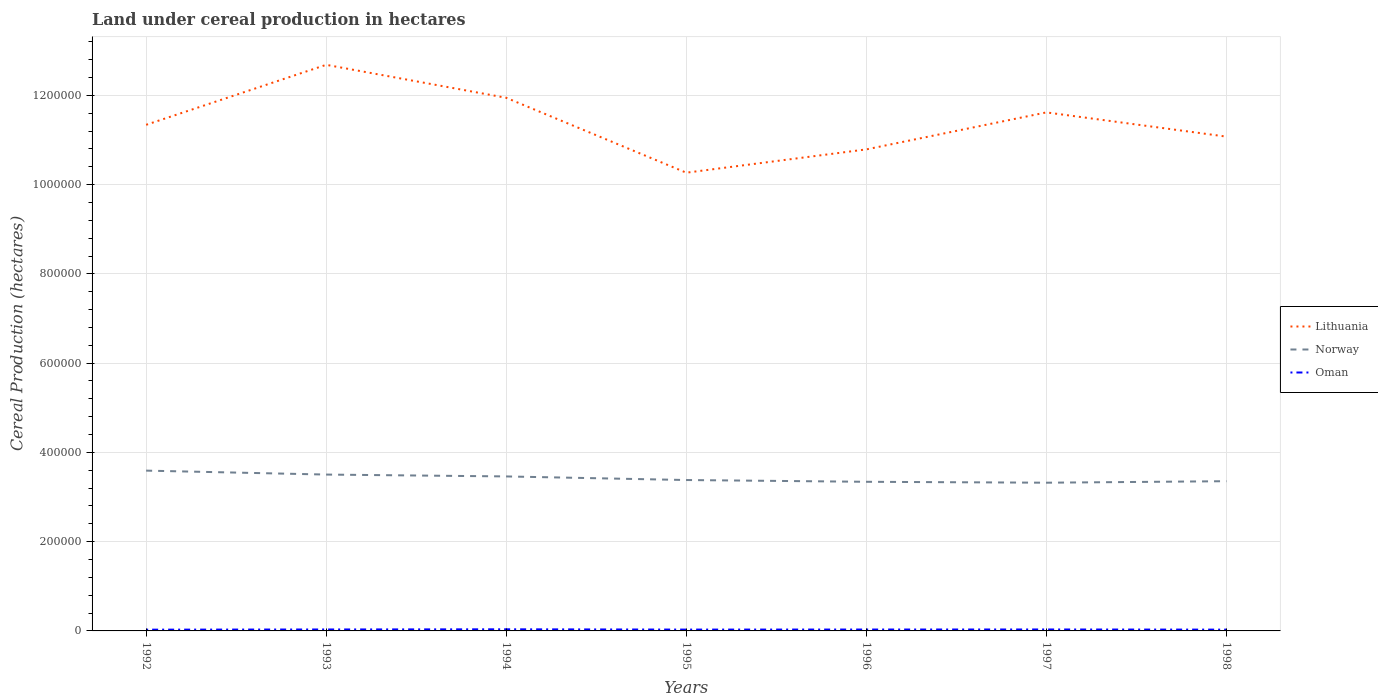How many different coloured lines are there?
Provide a short and direct response. 3. Across all years, what is the maximum land under cereal production in Oman?
Your response must be concise. 2814. What is the total land under cereal production in Oman in the graph?
Your answer should be compact. 126. What is the difference between the highest and the second highest land under cereal production in Oman?
Keep it short and to the point. 821. What is the difference between the highest and the lowest land under cereal production in Lithuania?
Your response must be concise. 3. How many years are there in the graph?
Your answer should be compact. 7. Does the graph contain any zero values?
Provide a short and direct response. No. Where does the legend appear in the graph?
Ensure brevity in your answer.  Center right. How are the legend labels stacked?
Your answer should be compact. Vertical. What is the title of the graph?
Provide a succinct answer. Land under cereal production in hectares. Does "Greece" appear as one of the legend labels in the graph?
Your answer should be very brief. No. What is the label or title of the Y-axis?
Give a very brief answer. Cereal Production (hectares). What is the Cereal Production (hectares) of Lithuania in 1992?
Offer a very short reply. 1.13e+06. What is the Cereal Production (hectares) in Norway in 1992?
Keep it short and to the point. 3.59e+05. What is the Cereal Production (hectares) in Oman in 1992?
Keep it short and to the point. 2814. What is the Cereal Production (hectares) in Lithuania in 1993?
Your answer should be very brief. 1.27e+06. What is the Cereal Production (hectares) of Norway in 1993?
Provide a succinct answer. 3.50e+05. What is the Cereal Production (hectares) in Oman in 1993?
Keep it short and to the point. 3246. What is the Cereal Production (hectares) in Lithuania in 1994?
Your response must be concise. 1.19e+06. What is the Cereal Production (hectares) in Norway in 1994?
Offer a very short reply. 3.46e+05. What is the Cereal Production (hectares) of Oman in 1994?
Keep it short and to the point. 3635. What is the Cereal Production (hectares) in Lithuania in 1995?
Your answer should be very brief. 1.03e+06. What is the Cereal Production (hectares) in Norway in 1995?
Provide a short and direct response. 3.38e+05. What is the Cereal Production (hectares) in Oman in 1995?
Keep it short and to the point. 2990. What is the Cereal Production (hectares) of Lithuania in 1996?
Give a very brief answer. 1.08e+06. What is the Cereal Production (hectares) of Norway in 1996?
Your response must be concise. 3.34e+05. What is the Cereal Production (hectares) in Oman in 1996?
Your answer should be compact. 3120. What is the Cereal Production (hectares) of Lithuania in 1997?
Provide a short and direct response. 1.16e+06. What is the Cereal Production (hectares) in Norway in 1997?
Your answer should be very brief. 3.32e+05. What is the Cereal Production (hectares) in Oman in 1997?
Make the answer very short. 3250. What is the Cereal Production (hectares) in Lithuania in 1998?
Keep it short and to the point. 1.11e+06. What is the Cereal Production (hectares) of Norway in 1998?
Your response must be concise. 3.35e+05. What is the Cereal Production (hectares) in Oman in 1998?
Your answer should be very brief. 2894. Across all years, what is the maximum Cereal Production (hectares) in Lithuania?
Ensure brevity in your answer.  1.27e+06. Across all years, what is the maximum Cereal Production (hectares) in Norway?
Offer a very short reply. 3.59e+05. Across all years, what is the maximum Cereal Production (hectares) of Oman?
Your answer should be compact. 3635. Across all years, what is the minimum Cereal Production (hectares) of Lithuania?
Offer a very short reply. 1.03e+06. Across all years, what is the minimum Cereal Production (hectares) in Norway?
Offer a very short reply. 3.32e+05. Across all years, what is the minimum Cereal Production (hectares) of Oman?
Make the answer very short. 2814. What is the total Cereal Production (hectares) of Lithuania in the graph?
Your response must be concise. 7.97e+06. What is the total Cereal Production (hectares) in Norway in the graph?
Make the answer very short. 2.40e+06. What is the total Cereal Production (hectares) in Oman in the graph?
Offer a very short reply. 2.19e+04. What is the difference between the Cereal Production (hectares) in Lithuania in 1992 and that in 1993?
Your answer should be compact. -1.34e+05. What is the difference between the Cereal Production (hectares) in Norway in 1992 and that in 1993?
Your answer should be compact. 8830. What is the difference between the Cereal Production (hectares) in Oman in 1992 and that in 1993?
Ensure brevity in your answer.  -432. What is the difference between the Cereal Production (hectares) in Lithuania in 1992 and that in 1994?
Your answer should be compact. -6.05e+04. What is the difference between the Cereal Production (hectares) of Norway in 1992 and that in 1994?
Provide a short and direct response. 1.30e+04. What is the difference between the Cereal Production (hectares) in Oman in 1992 and that in 1994?
Offer a very short reply. -821. What is the difference between the Cereal Production (hectares) of Lithuania in 1992 and that in 1995?
Keep it short and to the point. 1.07e+05. What is the difference between the Cereal Production (hectares) in Norway in 1992 and that in 1995?
Offer a terse response. 2.11e+04. What is the difference between the Cereal Production (hectares) of Oman in 1992 and that in 1995?
Keep it short and to the point. -176. What is the difference between the Cereal Production (hectares) of Lithuania in 1992 and that in 1996?
Provide a short and direct response. 5.51e+04. What is the difference between the Cereal Production (hectares) in Norway in 1992 and that in 1996?
Offer a terse response. 2.50e+04. What is the difference between the Cereal Production (hectares) in Oman in 1992 and that in 1996?
Offer a terse response. -306. What is the difference between the Cereal Production (hectares) of Lithuania in 1992 and that in 1997?
Provide a short and direct response. -2.78e+04. What is the difference between the Cereal Production (hectares) in Norway in 1992 and that in 1997?
Offer a very short reply. 2.71e+04. What is the difference between the Cereal Production (hectares) in Oman in 1992 and that in 1997?
Make the answer very short. -436. What is the difference between the Cereal Production (hectares) in Lithuania in 1992 and that in 1998?
Provide a short and direct response. 2.65e+04. What is the difference between the Cereal Production (hectares) in Norway in 1992 and that in 1998?
Your answer should be compact. 2.37e+04. What is the difference between the Cereal Production (hectares) in Oman in 1992 and that in 1998?
Make the answer very short. -80. What is the difference between the Cereal Production (hectares) of Lithuania in 1993 and that in 1994?
Keep it short and to the point. 7.39e+04. What is the difference between the Cereal Production (hectares) in Norway in 1993 and that in 1994?
Keep it short and to the point. 4185. What is the difference between the Cereal Production (hectares) in Oman in 1993 and that in 1994?
Make the answer very short. -389. What is the difference between the Cereal Production (hectares) of Lithuania in 1993 and that in 1995?
Offer a very short reply. 2.42e+05. What is the difference between the Cereal Production (hectares) in Norway in 1993 and that in 1995?
Keep it short and to the point. 1.22e+04. What is the difference between the Cereal Production (hectares) of Oman in 1993 and that in 1995?
Offer a terse response. 256. What is the difference between the Cereal Production (hectares) of Lithuania in 1993 and that in 1996?
Give a very brief answer. 1.90e+05. What is the difference between the Cereal Production (hectares) in Norway in 1993 and that in 1996?
Your response must be concise. 1.62e+04. What is the difference between the Cereal Production (hectares) of Oman in 1993 and that in 1996?
Offer a very short reply. 126. What is the difference between the Cereal Production (hectares) of Lithuania in 1993 and that in 1997?
Your answer should be very brief. 1.07e+05. What is the difference between the Cereal Production (hectares) of Norway in 1993 and that in 1997?
Ensure brevity in your answer.  1.82e+04. What is the difference between the Cereal Production (hectares) of Lithuania in 1993 and that in 1998?
Offer a terse response. 1.61e+05. What is the difference between the Cereal Production (hectares) in Norway in 1993 and that in 1998?
Offer a very short reply. 1.49e+04. What is the difference between the Cereal Production (hectares) in Oman in 1993 and that in 1998?
Provide a succinct answer. 352. What is the difference between the Cereal Production (hectares) in Lithuania in 1994 and that in 1995?
Offer a terse response. 1.68e+05. What is the difference between the Cereal Production (hectares) in Norway in 1994 and that in 1995?
Provide a short and direct response. 8060. What is the difference between the Cereal Production (hectares) of Oman in 1994 and that in 1995?
Ensure brevity in your answer.  645. What is the difference between the Cereal Production (hectares) in Lithuania in 1994 and that in 1996?
Your response must be concise. 1.16e+05. What is the difference between the Cereal Production (hectares) in Norway in 1994 and that in 1996?
Offer a very short reply. 1.20e+04. What is the difference between the Cereal Production (hectares) of Oman in 1994 and that in 1996?
Your answer should be very brief. 515. What is the difference between the Cereal Production (hectares) in Lithuania in 1994 and that in 1997?
Your answer should be compact. 3.27e+04. What is the difference between the Cereal Production (hectares) of Norway in 1994 and that in 1997?
Ensure brevity in your answer.  1.40e+04. What is the difference between the Cereal Production (hectares) in Oman in 1994 and that in 1997?
Provide a short and direct response. 385. What is the difference between the Cereal Production (hectares) of Lithuania in 1994 and that in 1998?
Provide a succinct answer. 8.70e+04. What is the difference between the Cereal Production (hectares) in Norway in 1994 and that in 1998?
Give a very brief answer. 1.07e+04. What is the difference between the Cereal Production (hectares) in Oman in 1994 and that in 1998?
Your answer should be very brief. 741. What is the difference between the Cereal Production (hectares) in Lithuania in 1995 and that in 1996?
Provide a succinct answer. -5.22e+04. What is the difference between the Cereal Production (hectares) of Norway in 1995 and that in 1996?
Offer a very short reply. 3950. What is the difference between the Cereal Production (hectares) in Oman in 1995 and that in 1996?
Provide a succinct answer. -130. What is the difference between the Cereal Production (hectares) in Lithuania in 1995 and that in 1997?
Keep it short and to the point. -1.35e+05. What is the difference between the Cereal Production (hectares) of Norway in 1995 and that in 1997?
Offer a very short reply. 5990. What is the difference between the Cereal Production (hectares) in Oman in 1995 and that in 1997?
Your response must be concise. -260. What is the difference between the Cereal Production (hectares) of Lithuania in 1995 and that in 1998?
Provide a succinct answer. -8.08e+04. What is the difference between the Cereal Production (hectares) in Norway in 1995 and that in 1998?
Offer a very short reply. 2630. What is the difference between the Cereal Production (hectares) in Oman in 1995 and that in 1998?
Your answer should be compact. 96. What is the difference between the Cereal Production (hectares) of Lithuania in 1996 and that in 1997?
Your response must be concise. -8.29e+04. What is the difference between the Cereal Production (hectares) of Norway in 1996 and that in 1997?
Your answer should be compact. 2040. What is the difference between the Cereal Production (hectares) of Oman in 1996 and that in 1997?
Make the answer very short. -130. What is the difference between the Cereal Production (hectares) of Lithuania in 1996 and that in 1998?
Your response must be concise. -2.86e+04. What is the difference between the Cereal Production (hectares) of Norway in 1996 and that in 1998?
Offer a very short reply. -1320. What is the difference between the Cereal Production (hectares) of Oman in 1996 and that in 1998?
Provide a succinct answer. 226. What is the difference between the Cereal Production (hectares) in Lithuania in 1997 and that in 1998?
Give a very brief answer. 5.43e+04. What is the difference between the Cereal Production (hectares) of Norway in 1997 and that in 1998?
Provide a short and direct response. -3360. What is the difference between the Cereal Production (hectares) in Oman in 1997 and that in 1998?
Ensure brevity in your answer.  356. What is the difference between the Cereal Production (hectares) of Lithuania in 1992 and the Cereal Production (hectares) of Norway in 1993?
Offer a very short reply. 7.84e+05. What is the difference between the Cereal Production (hectares) of Lithuania in 1992 and the Cereal Production (hectares) of Oman in 1993?
Your response must be concise. 1.13e+06. What is the difference between the Cereal Production (hectares) of Norway in 1992 and the Cereal Production (hectares) of Oman in 1993?
Provide a succinct answer. 3.56e+05. What is the difference between the Cereal Production (hectares) in Lithuania in 1992 and the Cereal Production (hectares) in Norway in 1994?
Provide a short and direct response. 7.88e+05. What is the difference between the Cereal Production (hectares) in Lithuania in 1992 and the Cereal Production (hectares) in Oman in 1994?
Provide a succinct answer. 1.13e+06. What is the difference between the Cereal Production (hectares) in Norway in 1992 and the Cereal Production (hectares) in Oman in 1994?
Ensure brevity in your answer.  3.56e+05. What is the difference between the Cereal Production (hectares) in Lithuania in 1992 and the Cereal Production (hectares) in Norway in 1995?
Offer a very short reply. 7.96e+05. What is the difference between the Cereal Production (hectares) in Lithuania in 1992 and the Cereal Production (hectares) in Oman in 1995?
Give a very brief answer. 1.13e+06. What is the difference between the Cereal Production (hectares) in Norway in 1992 and the Cereal Production (hectares) in Oman in 1995?
Your response must be concise. 3.56e+05. What is the difference between the Cereal Production (hectares) in Lithuania in 1992 and the Cereal Production (hectares) in Norway in 1996?
Make the answer very short. 8.00e+05. What is the difference between the Cereal Production (hectares) of Lithuania in 1992 and the Cereal Production (hectares) of Oman in 1996?
Your response must be concise. 1.13e+06. What is the difference between the Cereal Production (hectares) of Norway in 1992 and the Cereal Production (hectares) of Oman in 1996?
Provide a short and direct response. 3.56e+05. What is the difference between the Cereal Production (hectares) of Lithuania in 1992 and the Cereal Production (hectares) of Norway in 1997?
Your answer should be very brief. 8.02e+05. What is the difference between the Cereal Production (hectares) in Lithuania in 1992 and the Cereal Production (hectares) in Oman in 1997?
Give a very brief answer. 1.13e+06. What is the difference between the Cereal Production (hectares) in Norway in 1992 and the Cereal Production (hectares) in Oman in 1997?
Provide a short and direct response. 3.56e+05. What is the difference between the Cereal Production (hectares) of Lithuania in 1992 and the Cereal Production (hectares) of Norway in 1998?
Your answer should be very brief. 7.99e+05. What is the difference between the Cereal Production (hectares) of Lithuania in 1992 and the Cereal Production (hectares) of Oman in 1998?
Ensure brevity in your answer.  1.13e+06. What is the difference between the Cereal Production (hectares) of Norway in 1992 and the Cereal Production (hectares) of Oman in 1998?
Offer a very short reply. 3.56e+05. What is the difference between the Cereal Production (hectares) of Lithuania in 1993 and the Cereal Production (hectares) of Norway in 1994?
Provide a succinct answer. 9.22e+05. What is the difference between the Cereal Production (hectares) of Lithuania in 1993 and the Cereal Production (hectares) of Oman in 1994?
Provide a succinct answer. 1.26e+06. What is the difference between the Cereal Production (hectares) in Norway in 1993 and the Cereal Production (hectares) in Oman in 1994?
Provide a succinct answer. 3.47e+05. What is the difference between the Cereal Production (hectares) in Lithuania in 1993 and the Cereal Production (hectares) in Norway in 1995?
Your answer should be compact. 9.30e+05. What is the difference between the Cereal Production (hectares) in Lithuania in 1993 and the Cereal Production (hectares) in Oman in 1995?
Give a very brief answer. 1.27e+06. What is the difference between the Cereal Production (hectares) in Norway in 1993 and the Cereal Production (hectares) in Oman in 1995?
Your response must be concise. 3.47e+05. What is the difference between the Cereal Production (hectares) in Lithuania in 1993 and the Cereal Production (hectares) in Norway in 1996?
Your answer should be compact. 9.34e+05. What is the difference between the Cereal Production (hectares) of Lithuania in 1993 and the Cereal Production (hectares) of Oman in 1996?
Ensure brevity in your answer.  1.27e+06. What is the difference between the Cereal Production (hectares) of Norway in 1993 and the Cereal Production (hectares) of Oman in 1996?
Keep it short and to the point. 3.47e+05. What is the difference between the Cereal Production (hectares) in Lithuania in 1993 and the Cereal Production (hectares) in Norway in 1997?
Ensure brevity in your answer.  9.36e+05. What is the difference between the Cereal Production (hectares) in Lithuania in 1993 and the Cereal Production (hectares) in Oman in 1997?
Your answer should be very brief. 1.27e+06. What is the difference between the Cereal Production (hectares) in Norway in 1993 and the Cereal Production (hectares) in Oman in 1997?
Offer a very short reply. 3.47e+05. What is the difference between the Cereal Production (hectares) of Lithuania in 1993 and the Cereal Production (hectares) of Norway in 1998?
Keep it short and to the point. 9.33e+05. What is the difference between the Cereal Production (hectares) in Lithuania in 1993 and the Cereal Production (hectares) in Oman in 1998?
Provide a succinct answer. 1.27e+06. What is the difference between the Cereal Production (hectares) of Norway in 1993 and the Cereal Production (hectares) of Oman in 1998?
Keep it short and to the point. 3.47e+05. What is the difference between the Cereal Production (hectares) of Lithuania in 1994 and the Cereal Production (hectares) of Norway in 1995?
Your answer should be compact. 8.56e+05. What is the difference between the Cereal Production (hectares) of Lithuania in 1994 and the Cereal Production (hectares) of Oman in 1995?
Your answer should be compact. 1.19e+06. What is the difference between the Cereal Production (hectares) in Norway in 1994 and the Cereal Production (hectares) in Oman in 1995?
Give a very brief answer. 3.43e+05. What is the difference between the Cereal Production (hectares) of Lithuania in 1994 and the Cereal Production (hectares) of Norway in 1996?
Your answer should be compact. 8.60e+05. What is the difference between the Cereal Production (hectares) in Lithuania in 1994 and the Cereal Production (hectares) in Oman in 1996?
Your response must be concise. 1.19e+06. What is the difference between the Cereal Production (hectares) in Norway in 1994 and the Cereal Production (hectares) in Oman in 1996?
Give a very brief answer. 3.43e+05. What is the difference between the Cereal Production (hectares) in Lithuania in 1994 and the Cereal Production (hectares) in Norway in 1997?
Ensure brevity in your answer.  8.62e+05. What is the difference between the Cereal Production (hectares) in Lithuania in 1994 and the Cereal Production (hectares) in Oman in 1997?
Your response must be concise. 1.19e+06. What is the difference between the Cereal Production (hectares) of Norway in 1994 and the Cereal Production (hectares) of Oman in 1997?
Provide a succinct answer. 3.43e+05. What is the difference between the Cereal Production (hectares) in Lithuania in 1994 and the Cereal Production (hectares) in Norway in 1998?
Make the answer very short. 8.59e+05. What is the difference between the Cereal Production (hectares) in Lithuania in 1994 and the Cereal Production (hectares) in Oman in 1998?
Keep it short and to the point. 1.19e+06. What is the difference between the Cereal Production (hectares) of Norway in 1994 and the Cereal Production (hectares) of Oman in 1998?
Keep it short and to the point. 3.43e+05. What is the difference between the Cereal Production (hectares) of Lithuania in 1995 and the Cereal Production (hectares) of Norway in 1996?
Ensure brevity in your answer.  6.93e+05. What is the difference between the Cereal Production (hectares) in Lithuania in 1995 and the Cereal Production (hectares) in Oman in 1996?
Offer a very short reply. 1.02e+06. What is the difference between the Cereal Production (hectares) in Norway in 1995 and the Cereal Production (hectares) in Oman in 1996?
Your response must be concise. 3.35e+05. What is the difference between the Cereal Production (hectares) in Lithuania in 1995 and the Cereal Production (hectares) in Norway in 1997?
Your answer should be compact. 6.95e+05. What is the difference between the Cereal Production (hectares) in Lithuania in 1995 and the Cereal Production (hectares) in Oman in 1997?
Your response must be concise. 1.02e+06. What is the difference between the Cereal Production (hectares) of Norway in 1995 and the Cereal Production (hectares) of Oman in 1997?
Give a very brief answer. 3.35e+05. What is the difference between the Cereal Production (hectares) of Lithuania in 1995 and the Cereal Production (hectares) of Norway in 1998?
Keep it short and to the point. 6.91e+05. What is the difference between the Cereal Production (hectares) of Lithuania in 1995 and the Cereal Production (hectares) of Oman in 1998?
Give a very brief answer. 1.02e+06. What is the difference between the Cereal Production (hectares) in Norway in 1995 and the Cereal Production (hectares) in Oman in 1998?
Offer a terse response. 3.35e+05. What is the difference between the Cereal Production (hectares) in Lithuania in 1996 and the Cereal Production (hectares) in Norway in 1997?
Your response must be concise. 7.47e+05. What is the difference between the Cereal Production (hectares) of Lithuania in 1996 and the Cereal Production (hectares) of Oman in 1997?
Your answer should be compact. 1.08e+06. What is the difference between the Cereal Production (hectares) in Norway in 1996 and the Cereal Production (hectares) in Oman in 1997?
Make the answer very short. 3.31e+05. What is the difference between the Cereal Production (hectares) in Lithuania in 1996 and the Cereal Production (hectares) in Norway in 1998?
Ensure brevity in your answer.  7.43e+05. What is the difference between the Cereal Production (hectares) in Lithuania in 1996 and the Cereal Production (hectares) in Oman in 1998?
Your response must be concise. 1.08e+06. What is the difference between the Cereal Production (hectares) in Norway in 1996 and the Cereal Production (hectares) in Oman in 1998?
Your answer should be very brief. 3.31e+05. What is the difference between the Cereal Production (hectares) in Lithuania in 1997 and the Cereal Production (hectares) in Norway in 1998?
Give a very brief answer. 8.26e+05. What is the difference between the Cereal Production (hectares) in Lithuania in 1997 and the Cereal Production (hectares) in Oman in 1998?
Your answer should be compact. 1.16e+06. What is the difference between the Cereal Production (hectares) of Norway in 1997 and the Cereal Production (hectares) of Oman in 1998?
Provide a succinct answer. 3.29e+05. What is the average Cereal Production (hectares) of Lithuania per year?
Offer a very short reply. 1.14e+06. What is the average Cereal Production (hectares) in Norway per year?
Provide a short and direct response. 3.42e+05. What is the average Cereal Production (hectares) in Oman per year?
Provide a short and direct response. 3135.57. In the year 1992, what is the difference between the Cereal Production (hectares) in Lithuania and Cereal Production (hectares) in Norway?
Your answer should be very brief. 7.75e+05. In the year 1992, what is the difference between the Cereal Production (hectares) in Lithuania and Cereal Production (hectares) in Oman?
Your response must be concise. 1.13e+06. In the year 1992, what is the difference between the Cereal Production (hectares) in Norway and Cereal Production (hectares) in Oman?
Your answer should be very brief. 3.56e+05. In the year 1993, what is the difference between the Cereal Production (hectares) in Lithuania and Cereal Production (hectares) in Norway?
Provide a succinct answer. 9.18e+05. In the year 1993, what is the difference between the Cereal Production (hectares) in Lithuania and Cereal Production (hectares) in Oman?
Offer a very short reply. 1.27e+06. In the year 1993, what is the difference between the Cereal Production (hectares) of Norway and Cereal Production (hectares) of Oman?
Ensure brevity in your answer.  3.47e+05. In the year 1994, what is the difference between the Cereal Production (hectares) of Lithuania and Cereal Production (hectares) of Norway?
Your answer should be compact. 8.48e+05. In the year 1994, what is the difference between the Cereal Production (hectares) in Lithuania and Cereal Production (hectares) in Oman?
Your answer should be very brief. 1.19e+06. In the year 1994, what is the difference between the Cereal Production (hectares) of Norway and Cereal Production (hectares) of Oman?
Your answer should be very brief. 3.43e+05. In the year 1995, what is the difference between the Cereal Production (hectares) of Lithuania and Cereal Production (hectares) of Norway?
Ensure brevity in your answer.  6.89e+05. In the year 1995, what is the difference between the Cereal Production (hectares) in Lithuania and Cereal Production (hectares) in Oman?
Make the answer very short. 1.02e+06. In the year 1995, what is the difference between the Cereal Production (hectares) in Norway and Cereal Production (hectares) in Oman?
Ensure brevity in your answer.  3.35e+05. In the year 1996, what is the difference between the Cereal Production (hectares) of Lithuania and Cereal Production (hectares) of Norway?
Ensure brevity in your answer.  7.45e+05. In the year 1996, what is the difference between the Cereal Production (hectares) of Lithuania and Cereal Production (hectares) of Oman?
Provide a short and direct response. 1.08e+06. In the year 1996, what is the difference between the Cereal Production (hectares) in Norway and Cereal Production (hectares) in Oman?
Offer a very short reply. 3.31e+05. In the year 1997, what is the difference between the Cereal Production (hectares) in Lithuania and Cereal Production (hectares) in Norway?
Offer a terse response. 8.30e+05. In the year 1997, what is the difference between the Cereal Production (hectares) in Lithuania and Cereal Production (hectares) in Oman?
Provide a succinct answer. 1.16e+06. In the year 1997, what is the difference between the Cereal Production (hectares) of Norway and Cereal Production (hectares) of Oman?
Ensure brevity in your answer.  3.29e+05. In the year 1998, what is the difference between the Cereal Production (hectares) in Lithuania and Cereal Production (hectares) in Norway?
Give a very brief answer. 7.72e+05. In the year 1998, what is the difference between the Cereal Production (hectares) of Lithuania and Cereal Production (hectares) of Oman?
Give a very brief answer. 1.10e+06. In the year 1998, what is the difference between the Cereal Production (hectares) of Norway and Cereal Production (hectares) of Oman?
Offer a very short reply. 3.33e+05. What is the ratio of the Cereal Production (hectares) of Lithuania in 1992 to that in 1993?
Keep it short and to the point. 0.89. What is the ratio of the Cereal Production (hectares) in Norway in 1992 to that in 1993?
Offer a terse response. 1.03. What is the ratio of the Cereal Production (hectares) of Oman in 1992 to that in 1993?
Your answer should be very brief. 0.87. What is the ratio of the Cereal Production (hectares) in Lithuania in 1992 to that in 1994?
Keep it short and to the point. 0.95. What is the ratio of the Cereal Production (hectares) of Norway in 1992 to that in 1994?
Offer a terse response. 1.04. What is the ratio of the Cereal Production (hectares) in Oman in 1992 to that in 1994?
Provide a short and direct response. 0.77. What is the ratio of the Cereal Production (hectares) in Lithuania in 1992 to that in 1995?
Keep it short and to the point. 1.1. What is the ratio of the Cereal Production (hectares) in Norway in 1992 to that in 1995?
Give a very brief answer. 1.06. What is the ratio of the Cereal Production (hectares) in Oman in 1992 to that in 1995?
Give a very brief answer. 0.94. What is the ratio of the Cereal Production (hectares) in Lithuania in 1992 to that in 1996?
Provide a succinct answer. 1.05. What is the ratio of the Cereal Production (hectares) of Norway in 1992 to that in 1996?
Your response must be concise. 1.07. What is the ratio of the Cereal Production (hectares) of Oman in 1992 to that in 1996?
Offer a terse response. 0.9. What is the ratio of the Cereal Production (hectares) in Lithuania in 1992 to that in 1997?
Your answer should be compact. 0.98. What is the ratio of the Cereal Production (hectares) of Norway in 1992 to that in 1997?
Your answer should be compact. 1.08. What is the ratio of the Cereal Production (hectares) of Oman in 1992 to that in 1997?
Offer a very short reply. 0.87. What is the ratio of the Cereal Production (hectares) of Lithuania in 1992 to that in 1998?
Provide a succinct answer. 1.02. What is the ratio of the Cereal Production (hectares) of Norway in 1992 to that in 1998?
Keep it short and to the point. 1.07. What is the ratio of the Cereal Production (hectares) of Oman in 1992 to that in 1998?
Provide a succinct answer. 0.97. What is the ratio of the Cereal Production (hectares) of Lithuania in 1993 to that in 1994?
Offer a very short reply. 1.06. What is the ratio of the Cereal Production (hectares) of Norway in 1993 to that in 1994?
Keep it short and to the point. 1.01. What is the ratio of the Cereal Production (hectares) in Oman in 1993 to that in 1994?
Your answer should be very brief. 0.89. What is the ratio of the Cereal Production (hectares) of Lithuania in 1993 to that in 1995?
Give a very brief answer. 1.24. What is the ratio of the Cereal Production (hectares) of Norway in 1993 to that in 1995?
Your answer should be compact. 1.04. What is the ratio of the Cereal Production (hectares) in Oman in 1993 to that in 1995?
Offer a very short reply. 1.09. What is the ratio of the Cereal Production (hectares) of Lithuania in 1993 to that in 1996?
Ensure brevity in your answer.  1.18. What is the ratio of the Cereal Production (hectares) of Norway in 1993 to that in 1996?
Ensure brevity in your answer.  1.05. What is the ratio of the Cereal Production (hectares) of Oman in 1993 to that in 1996?
Ensure brevity in your answer.  1.04. What is the ratio of the Cereal Production (hectares) of Lithuania in 1993 to that in 1997?
Your answer should be very brief. 1.09. What is the ratio of the Cereal Production (hectares) of Norway in 1993 to that in 1997?
Give a very brief answer. 1.05. What is the ratio of the Cereal Production (hectares) of Oman in 1993 to that in 1997?
Offer a very short reply. 1. What is the ratio of the Cereal Production (hectares) in Lithuania in 1993 to that in 1998?
Provide a succinct answer. 1.15. What is the ratio of the Cereal Production (hectares) of Norway in 1993 to that in 1998?
Provide a short and direct response. 1.04. What is the ratio of the Cereal Production (hectares) of Oman in 1993 to that in 1998?
Offer a very short reply. 1.12. What is the ratio of the Cereal Production (hectares) of Lithuania in 1994 to that in 1995?
Your answer should be very brief. 1.16. What is the ratio of the Cereal Production (hectares) in Norway in 1994 to that in 1995?
Offer a very short reply. 1.02. What is the ratio of the Cereal Production (hectares) in Oman in 1994 to that in 1995?
Your answer should be compact. 1.22. What is the ratio of the Cereal Production (hectares) of Lithuania in 1994 to that in 1996?
Ensure brevity in your answer.  1.11. What is the ratio of the Cereal Production (hectares) in Norway in 1994 to that in 1996?
Your answer should be compact. 1.04. What is the ratio of the Cereal Production (hectares) of Oman in 1994 to that in 1996?
Make the answer very short. 1.17. What is the ratio of the Cereal Production (hectares) of Lithuania in 1994 to that in 1997?
Ensure brevity in your answer.  1.03. What is the ratio of the Cereal Production (hectares) of Norway in 1994 to that in 1997?
Make the answer very short. 1.04. What is the ratio of the Cereal Production (hectares) in Oman in 1994 to that in 1997?
Keep it short and to the point. 1.12. What is the ratio of the Cereal Production (hectares) in Lithuania in 1994 to that in 1998?
Make the answer very short. 1.08. What is the ratio of the Cereal Production (hectares) in Norway in 1994 to that in 1998?
Provide a short and direct response. 1.03. What is the ratio of the Cereal Production (hectares) of Oman in 1994 to that in 1998?
Your answer should be compact. 1.26. What is the ratio of the Cereal Production (hectares) of Lithuania in 1995 to that in 1996?
Offer a very short reply. 0.95. What is the ratio of the Cereal Production (hectares) of Norway in 1995 to that in 1996?
Offer a terse response. 1.01. What is the ratio of the Cereal Production (hectares) in Oman in 1995 to that in 1996?
Make the answer very short. 0.96. What is the ratio of the Cereal Production (hectares) in Lithuania in 1995 to that in 1997?
Keep it short and to the point. 0.88. What is the ratio of the Cereal Production (hectares) of Norway in 1995 to that in 1997?
Your response must be concise. 1.02. What is the ratio of the Cereal Production (hectares) in Lithuania in 1995 to that in 1998?
Ensure brevity in your answer.  0.93. What is the ratio of the Cereal Production (hectares) in Norway in 1995 to that in 1998?
Your answer should be compact. 1.01. What is the ratio of the Cereal Production (hectares) in Oman in 1995 to that in 1998?
Provide a short and direct response. 1.03. What is the ratio of the Cereal Production (hectares) of Lithuania in 1996 to that in 1997?
Ensure brevity in your answer.  0.93. What is the ratio of the Cereal Production (hectares) in Lithuania in 1996 to that in 1998?
Make the answer very short. 0.97. What is the ratio of the Cereal Production (hectares) of Oman in 1996 to that in 1998?
Give a very brief answer. 1.08. What is the ratio of the Cereal Production (hectares) of Lithuania in 1997 to that in 1998?
Offer a very short reply. 1.05. What is the ratio of the Cereal Production (hectares) of Norway in 1997 to that in 1998?
Ensure brevity in your answer.  0.99. What is the ratio of the Cereal Production (hectares) in Oman in 1997 to that in 1998?
Offer a very short reply. 1.12. What is the difference between the highest and the second highest Cereal Production (hectares) of Lithuania?
Offer a terse response. 7.39e+04. What is the difference between the highest and the second highest Cereal Production (hectares) of Norway?
Your response must be concise. 8830. What is the difference between the highest and the second highest Cereal Production (hectares) in Oman?
Your answer should be compact. 385. What is the difference between the highest and the lowest Cereal Production (hectares) of Lithuania?
Provide a succinct answer. 2.42e+05. What is the difference between the highest and the lowest Cereal Production (hectares) in Norway?
Keep it short and to the point. 2.71e+04. What is the difference between the highest and the lowest Cereal Production (hectares) in Oman?
Make the answer very short. 821. 